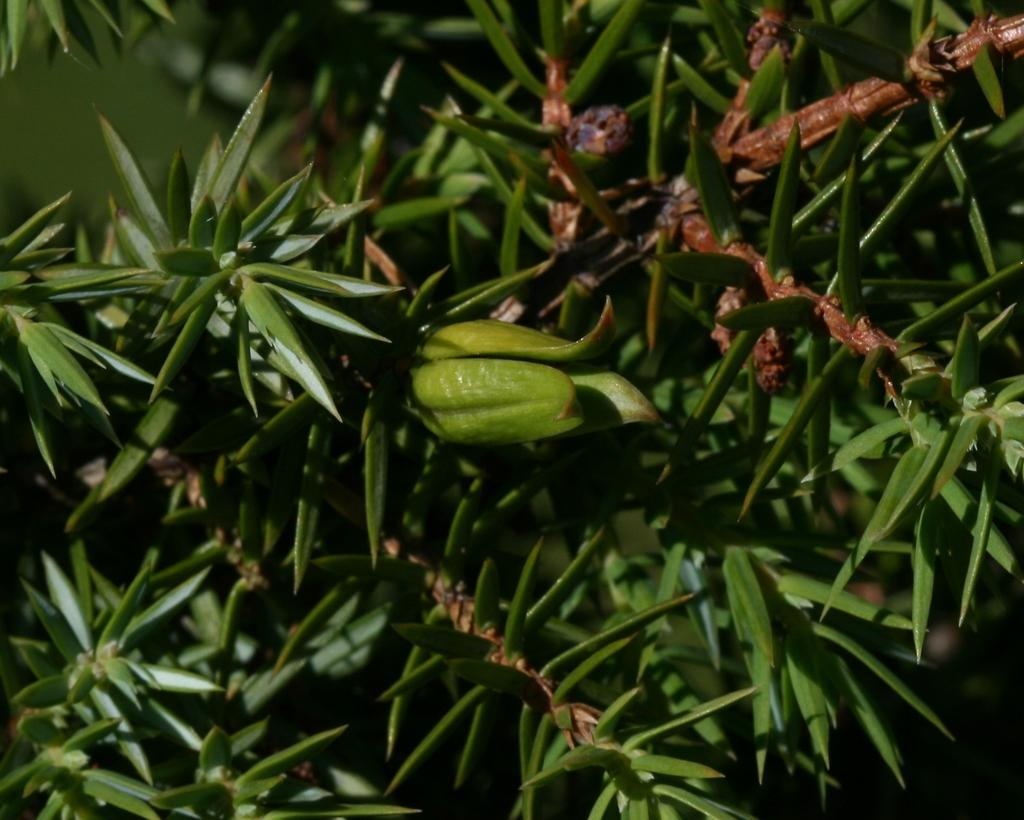What type of plant is in the image? There is a green plant in the image. What color are the leaves of the plant? The plant has green leaves. What color are the stems of the plant? The plant has brown stems. What direction is the wind blowing in the image? There is no wind present in the image, so it cannot be determined which direction the wind is blowing. 